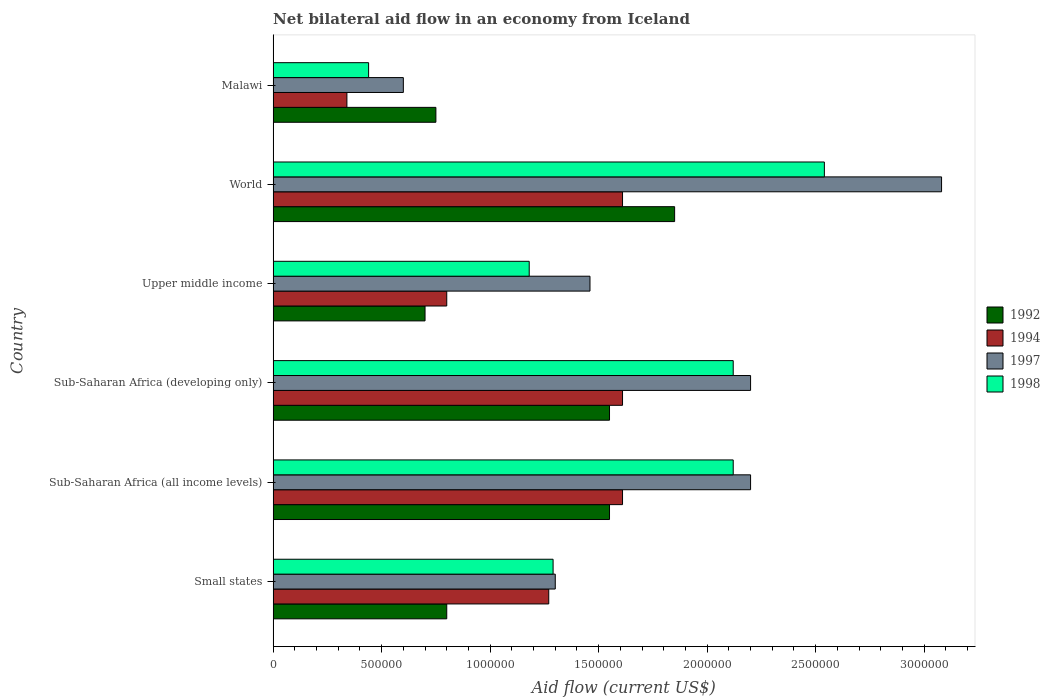How many groups of bars are there?
Provide a succinct answer. 6. Are the number of bars per tick equal to the number of legend labels?
Keep it short and to the point. Yes. Are the number of bars on each tick of the Y-axis equal?
Your answer should be compact. Yes. What is the label of the 4th group of bars from the top?
Your answer should be very brief. Sub-Saharan Africa (developing only). What is the net bilateral aid flow in 1997 in Upper middle income?
Your response must be concise. 1.46e+06. Across all countries, what is the maximum net bilateral aid flow in 1994?
Your response must be concise. 1.61e+06. Across all countries, what is the minimum net bilateral aid flow in 1994?
Provide a succinct answer. 3.40e+05. In which country was the net bilateral aid flow in 1992 minimum?
Give a very brief answer. Upper middle income. What is the total net bilateral aid flow in 1992 in the graph?
Offer a very short reply. 7.20e+06. What is the difference between the net bilateral aid flow in 1998 in Malawi and that in World?
Your answer should be compact. -2.10e+06. What is the difference between the net bilateral aid flow in 1994 in Sub-Saharan Africa (all income levels) and the net bilateral aid flow in 1992 in World?
Offer a very short reply. -2.40e+05. What is the average net bilateral aid flow in 1998 per country?
Make the answer very short. 1.62e+06. What is the difference between the net bilateral aid flow in 1998 and net bilateral aid flow in 1997 in Malawi?
Make the answer very short. -1.60e+05. What is the ratio of the net bilateral aid flow in 1998 in Malawi to that in World?
Keep it short and to the point. 0.17. What is the difference between the highest and the second highest net bilateral aid flow in 1997?
Make the answer very short. 8.80e+05. What is the difference between the highest and the lowest net bilateral aid flow in 1997?
Ensure brevity in your answer.  2.48e+06. What does the 3rd bar from the bottom in Upper middle income represents?
Your answer should be compact. 1997. Is it the case that in every country, the sum of the net bilateral aid flow in 1997 and net bilateral aid flow in 1992 is greater than the net bilateral aid flow in 1994?
Your answer should be very brief. Yes. Are all the bars in the graph horizontal?
Provide a short and direct response. Yes. Does the graph contain grids?
Make the answer very short. No. Where does the legend appear in the graph?
Your answer should be very brief. Center right. How are the legend labels stacked?
Keep it short and to the point. Vertical. What is the title of the graph?
Your answer should be compact. Net bilateral aid flow in an economy from Iceland. What is the Aid flow (current US$) of 1994 in Small states?
Your answer should be compact. 1.27e+06. What is the Aid flow (current US$) in 1997 in Small states?
Your response must be concise. 1.30e+06. What is the Aid flow (current US$) in 1998 in Small states?
Your answer should be compact. 1.29e+06. What is the Aid flow (current US$) of 1992 in Sub-Saharan Africa (all income levels)?
Keep it short and to the point. 1.55e+06. What is the Aid flow (current US$) of 1994 in Sub-Saharan Africa (all income levels)?
Your response must be concise. 1.61e+06. What is the Aid flow (current US$) of 1997 in Sub-Saharan Africa (all income levels)?
Provide a succinct answer. 2.20e+06. What is the Aid flow (current US$) of 1998 in Sub-Saharan Africa (all income levels)?
Keep it short and to the point. 2.12e+06. What is the Aid flow (current US$) in 1992 in Sub-Saharan Africa (developing only)?
Your response must be concise. 1.55e+06. What is the Aid flow (current US$) in 1994 in Sub-Saharan Africa (developing only)?
Provide a short and direct response. 1.61e+06. What is the Aid flow (current US$) in 1997 in Sub-Saharan Africa (developing only)?
Ensure brevity in your answer.  2.20e+06. What is the Aid flow (current US$) in 1998 in Sub-Saharan Africa (developing only)?
Ensure brevity in your answer.  2.12e+06. What is the Aid flow (current US$) of 1992 in Upper middle income?
Give a very brief answer. 7.00e+05. What is the Aid flow (current US$) of 1994 in Upper middle income?
Provide a short and direct response. 8.00e+05. What is the Aid flow (current US$) in 1997 in Upper middle income?
Keep it short and to the point. 1.46e+06. What is the Aid flow (current US$) in 1998 in Upper middle income?
Offer a terse response. 1.18e+06. What is the Aid flow (current US$) of 1992 in World?
Make the answer very short. 1.85e+06. What is the Aid flow (current US$) of 1994 in World?
Your response must be concise. 1.61e+06. What is the Aid flow (current US$) in 1997 in World?
Provide a succinct answer. 3.08e+06. What is the Aid flow (current US$) of 1998 in World?
Provide a succinct answer. 2.54e+06. What is the Aid flow (current US$) of 1992 in Malawi?
Your answer should be very brief. 7.50e+05. Across all countries, what is the maximum Aid flow (current US$) in 1992?
Ensure brevity in your answer.  1.85e+06. Across all countries, what is the maximum Aid flow (current US$) of 1994?
Provide a succinct answer. 1.61e+06. Across all countries, what is the maximum Aid flow (current US$) of 1997?
Ensure brevity in your answer.  3.08e+06. Across all countries, what is the maximum Aid flow (current US$) of 1998?
Your answer should be very brief. 2.54e+06. Across all countries, what is the minimum Aid flow (current US$) of 1992?
Offer a very short reply. 7.00e+05. Across all countries, what is the minimum Aid flow (current US$) in 1997?
Offer a very short reply. 6.00e+05. What is the total Aid flow (current US$) in 1992 in the graph?
Keep it short and to the point. 7.20e+06. What is the total Aid flow (current US$) in 1994 in the graph?
Offer a very short reply. 7.24e+06. What is the total Aid flow (current US$) of 1997 in the graph?
Offer a terse response. 1.08e+07. What is the total Aid flow (current US$) in 1998 in the graph?
Your response must be concise. 9.69e+06. What is the difference between the Aid flow (current US$) in 1992 in Small states and that in Sub-Saharan Africa (all income levels)?
Your answer should be compact. -7.50e+05. What is the difference between the Aid flow (current US$) in 1997 in Small states and that in Sub-Saharan Africa (all income levels)?
Provide a succinct answer. -9.00e+05. What is the difference between the Aid flow (current US$) of 1998 in Small states and that in Sub-Saharan Africa (all income levels)?
Provide a short and direct response. -8.30e+05. What is the difference between the Aid flow (current US$) of 1992 in Small states and that in Sub-Saharan Africa (developing only)?
Make the answer very short. -7.50e+05. What is the difference between the Aid flow (current US$) in 1997 in Small states and that in Sub-Saharan Africa (developing only)?
Offer a terse response. -9.00e+05. What is the difference between the Aid flow (current US$) of 1998 in Small states and that in Sub-Saharan Africa (developing only)?
Ensure brevity in your answer.  -8.30e+05. What is the difference between the Aid flow (current US$) in 1992 in Small states and that in Upper middle income?
Offer a very short reply. 1.00e+05. What is the difference between the Aid flow (current US$) of 1994 in Small states and that in Upper middle income?
Provide a short and direct response. 4.70e+05. What is the difference between the Aid flow (current US$) in 1992 in Small states and that in World?
Offer a terse response. -1.05e+06. What is the difference between the Aid flow (current US$) in 1994 in Small states and that in World?
Offer a terse response. -3.40e+05. What is the difference between the Aid flow (current US$) of 1997 in Small states and that in World?
Offer a very short reply. -1.78e+06. What is the difference between the Aid flow (current US$) in 1998 in Small states and that in World?
Provide a succinct answer. -1.25e+06. What is the difference between the Aid flow (current US$) in 1994 in Small states and that in Malawi?
Offer a very short reply. 9.30e+05. What is the difference between the Aid flow (current US$) in 1997 in Small states and that in Malawi?
Ensure brevity in your answer.  7.00e+05. What is the difference between the Aid flow (current US$) in 1998 in Small states and that in Malawi?
Keep it short and to the point. 8.50e+05. What is the difference between the Aid flow (current US$) in 1997 in Sub-Saharan Africa (all income levels) and that in Sub-Saharan Africa (developing only)?
Ensure brevity in your answer.  0. What is the difference between the Aid flow (current US$) of 1992 in Sub-Saharan Africa (all income levels) and that in Upper middle income?
Make the answer very short. 8.50e+05. What is the difference between the Aid flow (current US$) in 1994 in Sub-Saharan Africa (all income levels) and that in Upper middle income?
Offer a terse response. 8.10e+05. What is the difference between the Aid flow (current US$) of 1997 in Sub-Saharan Africa (all income levels) and that in Upper middle income?
Offer a very short reply. 7.40e+05. What is the difference between the Aid flow (current US$) in 1998 in Sub-Saharan Africa (all income levels) and that in Upper middle income?
Offer a very short reply. 9.40e+05. What is the difference between the Aid flow (current US$) in 1992 in Sub-Saharan Africa (all income levels) and that in World?
Ensure brevity in your answer.  -3.00e+05. What is the difference between the Aid flow (current US$) of 1994 in Sub-Saharan Africa (all income levels) and that in World?
Offer a terse response. 0. What is the difference between the Aid flow (current US$) of 1997 in Sub-Saharan Africa (all income levels) and that in World?
Give a very brief answer. -8.80e+05. What is the difference between the Aid flow (current US$) in 1998 in Sub-Saharan Africa (all income levels) and that in World?
Give a very brief answer. -4.20e+05. What is the difference between the Aid flow (current US$) in 1992 in Sub-Saharan Africa (all income levels) and that in Malawi?
Offer a terse response. 8.00e+05. What is the difference between the Aid flow (current US$) of 1994 in Sub-Saharan Africa (all income levels) and that in Malawi?
Keep it short and to the point. 1.27e+06. What is the difference between the Aid flow (current US$) of 1997 in Sub-Saharan Africa (all income levels) and that in Malawi?
Offer a terse response. 1.60e+06. What is the difference between the Aid flow (current US$) in 1998 in Sub-Saharan Africa (all income levels) and that in Malawi?
Keep it short and to the point. 1.68e+06. What is the difference between the Aid flow (current US$) of 1992 in Sub-Saharan Africa (developing only) and that in Upper middle income?
Give a very brief answer. 8.50e+05. What is the difference between the Aid flow (current US$) in 1994 in Sub-Saharan Africa (developing only) and that in Upper middle income?
Your answer should be very brief. 8.10e+05. What is the difference between the Aid flow (current US$) in 1997 in Sub-Saharan Africa (developing only) and that in Upper middle income?
Ensure brevity in your answer.  7.40e+05. What is the difference between the Aid flow (current US$) in 1998 in Sub-Saharan Africa (developing only) and that in Upper middle income?
Offer a very short reply. 9.40e+05. What is the difference between the Aid flow (current US$) in 1992 in Sub-Saharan Africa (developing only) and that in World?
Give a very brief answer. -3.00e+05. What is the difference between the Aid flow (current US$) in 1994 in Sub-Saharan Africa (developing only) and that in World?
Offer a terse response. 0. What is the difference between the Aid flow (current US$) in 1997 in Sub-Saharan Africa (developing only) and that in World?
Your answer should be very brief. -8.80e+05. What is the difference between the Aid flow (current US$) in 1998 in Sub-Saharan Africa (developing only) and that in World?
Your answer should be compact. -4.20e+05. What is the difference between the Aid flow (current US$) in 1992 in Sub-Saharan Africa (developing only) and that in Malawi?
Keep it short and to the point. 8.00e+05. What is the difference between the Aid flow (current US$) in 1994 in Sub-Saharan Africa (developing only) and that in Malawi?
Give a very brief answer. 1.27e+06. What is the difference between the Aid flow (current US$) in 1997 in Sub-Saharan Africa (developing only) and that in Malawi?
Your answer should be very brief. 1.60e+06. What is the difference between the Aid flow (current US$) of 1998 in Sub-Saharan Africa (developing only) and that in Malawi?
Your response must be concise. 1.68e+06. What is the difference between the Aid flow (current US$) in 1992 in Upper middle income and that in World?
Your answer should be very brief. -1.15e+06. What is the difference between the Aid flow (current US$) of 1994 in Upper middle income and that in World?
Provide a short and direct response. -8.10e+05. What is the difference between the Aid flow (current US$) of 1997 in Upper middle income and that in World?
Make the answer very short. -1.62e+06. What is the difference between the Aid flow (current US$) of 1998 in Upper middle income and that in World?
Your response must be concise. -1.36e+06. What is the difference between the Aid flow (current US$) of 1992 in Upper middle income and that in Malawi?
Give a very brief answer. -5.00e+04. What is the difference between the Aid flow (current US$) in 1997 in Upper middle income and that in Malawi?
Provide a short and direct response. 8.60e+05. What is the difference between the Aid flow (current US$) of 1998 in Upper middle income and that in Malawi?
Ensure brevity in your answer.  7.40e+05. What is the difference between the Aid flow (current US$) of 1992 in World and that in Malawi?
Provide a succinct answer. 1.10e+06. What is the difference between the Aid flow (current US$) of 1994 in World and that in Malawi?
Your response must be concise. 1.27e+06. What is the difference between the Aid flow (current US$) in 1997 in World and that in Malawi?
Provide a short and direct response. 2.48e+06. What is the difference between the Aid flow (current US$) of 1998 in World and that in Malawi?
Your answer should be very brief. 2.10e+06. What is the difference between the Aid flow (current US$) of 1992 in Small states and the Aid flow (current US$) of 1994 in Sub-Saharan Africa (all income levels)?
Keep it short and to the point. -8.10e+05. What is the difference between the Aid flow (current US$) of 1992 in Small states and the Aid flow (current US$) of 1997 in Sub-Saharan Africa (all income levels)?
Provide a succinct answer. -1.40e+06. What is the difference between the Aid flow (current US$) in 1992 in Small states and the Aid flow (current US$) in 1998 in Sub-Saharan Africa (all income levels)?
Provide a short and direct response. -1.32e+06. What is the difference between the Aid flow (current US$) of 1994 in Small states and the Aid flow (current US$) of 1997 in Sub-Saharan Africa (all income levels)?
Ensure brevity in your answer.  -9.30e+05. What is the difference between the Aid flow (current US$) in 1994 in Small states and the Aid flow (current US$) in 1998 in Sub-Saharan Africa (all income levels)?
Your answer should be very brief. -8.50e+05. What is the difference between the Aid flow (current US$) of 1997 in Small states and the Aid flow (current US$) of 1998 in Sub-Saharan Africa (all income levels)?
Provide a succinct answer. -8.20e+05. What is the difference between the Aid flow (current US$) of 1992 in Small states and the Aid flow (current US$) of 1994 in Sub-Saharan Africa (developing only)?
Your answer should be compact. -8.10e+05. What is the difference between the Aid flow (current US$) of 1992 in Small states and the Aid flow (current US$) of 1997 in Sub-Saharan Africa (developing only)?
Provide a short and direct response. -1.40e+06. What is the difference between the Aid flow (current US$) of 1992 in Small states and the Aid flow (current US$) of 1998 in Sub-Saharan Africa (developing only)?
Offer a very short reply. -1.32e+06. What is the difference between the Aid flow (current US$) of 1994 in Small states and the Aid flow (current US$) of 1997 in Sub-Saharan Africa (developing only)?
Offer a terse response. -9.30e+05. What is the difference between the Aid flow (current US$) in 1994 in Small states and the Aid flow (current US$) in 1998 in Sub-Saharan Africa (developing only)?
Provide a succinct answer. -8.50e+05. What is the difference between the Aid flow (current US$) of 1997 in Small states and the Aid flow (current US$) of 1998 in Sub-Saharan Africa (developing only)?
Ensure brevity in your answer.  -8.20e+05. What is the difference between the Aid flow (current US$) of 1992 in Small states and the Aid flow (current US$) of 1997 in Upper middle income?
Your answer should be compact. -6.60e+05. What is the difference between the Aid flow (current US$) of 1992 in Small states and the Aid flow (current US$) of 1998 in Upper middle income?
Provide a succinct answer. -3.80e+05. What is the difference between the Aid flow (current US$) in 1994 in Small states and the Aid flow (current US$) in 1997 in Upper middle income?
Your answer should be compact. -1.90e+05. What is the difference between the Aid flow (current US$) in 1992 in Small states and the Aid flow (current US$) in 1994 in World?
Offer a terse response. -8.10e+05. What is the difference between the Aid flow (current US$) of 1992 in Small states and the Aid flow (current US$) of 1997 in World?
Your answer should be compact. -2.28e+06. What is the difference between the Aid flow (current US$) of 1992 in Small states and the Aid flow (current US$) of 1998 in World?
Your answer should be compact. -1.74e+06. What is the difference between the Aid flow (current US$) of 1994 in Small states and the Aid flow (current US$) of 1997 in World?
Your response must be concise. -1.81e+06. What is the difference between the Aid flow (current US$) of 1994 in Small states and the Aid flow (current US$) of 1998 in World?
Keep it short and to the point. -1.27e+06. What is the difference between the Aid flow (current US$) in 1997 in Small states and the Aid flow (current US$) in 1998 in World?
Your response must be concise. -1.24e+06. What is the difference between the Aid flow (current US$) in 1992 in Small states and the Aid flow (current US$) in 1997 in Malawi?
Provide a succinct answer. 2.00e+05. What is the difference between the Aid flow (current US$) of 1994 in Small states and the Aid flow (current US$) of 1997 in Malawi?
Offer a terse response. 6.70e+05. What is the difference between the Aid flow (current US$) in 1994 in Small states and the Aid flow (current US$) in 1998 in Malawi?
Make the answer very short. 8.30e+05. What is the difference between the Aid flow (current US$) of 1997 in Small states and the Aid flow (current US$) of 1998 in Malawi?
Your response must be concise. 8.60e+05. What is the difference between the Aid flow (current US$) of 1992 in Sub-Saharan Africa (all income levels) and the Aid flow (current US$) of 1997 in Sub-Saharan Africa (developing only)?
Provide a short and direct response. -6.50e+05. What is the difference between the Aid flow (current US$) in 1992 in Sub-Saharan Africa (all income levels) and the Aid flow (current US$) in 1998 in Sub-Saharan Africa (developing only)?
Ensure brevity in your answer.  -5.70e+05. What is the difference between the Aid flow (current US$) of 1994 in Sub-Saharan Africa (all income levels) and the Aid flow (current US$) of 1997 in Sub-Saharan Africa (developing only)?
Provide a succinct answer. -5.90e+05. What is the difference between the Aid flow (current US$) in 1994 in Sub-Saharan Africa (all income levels) and the Aid flow (current US$) in 1998 in Sub-Saharan Africa (developing only)?
Your answer should be compact. -5.10e+05. What is the difference between the Aid flow (current US$) of 1992 in Sub-Saharan Africa (all income levels) and the Aid flow (current US$) of 1994 in Upper middle income?
Provide a short and direct response. 7.50e+05. What is the difference between the Aid flow (current US$) of 1992 in Sub-Saharan Africa (all income levels) and the Aid flow (current US$) of 1997 in Upper middle income?
Provide a short and direct response. 9.00e+04. What is the difference between the Aid flow (current US$) in 1997 in Sub-Saharan Africa (all income levels) and the Aid flow (current US$) in 1998 in Upper middle income?
Ensure brevity in your answer.  1.02e+06. What is the difference between the Aid flow (current US$) in 1992 in Sub-Saharan Africa (all income levels) and the Aid flow (current US$) in 1997 in World?
Your answer should be very brief. -1.53e+06. What is the difference between the Aid flow (current US$) of 1992 in Sub-Saharan Africa (all income levels) and the Aid flow (current US$) of 1998 in World?
Your answer should be very brief. -9.90e+05. What is the difference between the Aid flow (current US$) in 1994 in Sub-Saharan Africa (all income levels) and the Aid flow (current US$) in 1997 in World?
Your response must be concise. -1.47e+06. What is the difference between the Aid flow (current US$) of 1994 in Sub-Saharan Africa (all income levels) and the Aid flow (current US$) of 1998 in World?
Provide a succinct answer. -9.30e+05. What is the difference between the Aid flow (current US$) in 1992 in Sub-Saharan Africa (all income levels) and the Aid flow (current US$) in 1994 in Malawi?
Make the answer very short. 1.21e+06. What is the difference between the Aid flow (current US$) of 1992 in Sub-Saharan Africa (all income levels) and the Aid flow (current US$) of 1997 in Malawi?
Provide a short and direct response. 9.50e+05. What is the difference between the Aid flow (current US$) in 1992 in Sub-Saharan Africa (all income levels) and the Aid flow (current US$) in 1998 in Malawi?
Provide a short and direct response. 1.11e+06. What is the difference between the Aid flow (current US$) of 1994 in Sub-Saharan Africa (all income levels) and the Aid flow (current US$) of 1997 in Malawi?
Make the answer very short. 1.01e+06. What is the difference between the Aid flow (current US$) of 1994 in Sub-Saharan Africa (all income levels) and the Aid flow (current US$) of 1998 in Malawi?
Your answer should be compact. 1.17e+06. What is the difference between the Aid flow (current US$) of 1997 in Sub-Saharan Africa (all income levels) and the Aid flow (current US$) of 1998 in Malawi?
Provide a short and direct response. 1.76e+06. What is the difference between the Aid flow (current US$) of 1992 in Sub-Saharan Africa (developing only) and the Aid flow (current US$) of 1994 in Upper middle income?
Offer a very short reply. 7.50e+05. What is the difference between the Aid flow (current US$) in 1992 in Sub-Saharan Africa (developing only) and the Aid flow (current US$) in 1998 in Upper middle income?
Keep it short and to the point. 3.70e+05. What is the difference between the Aid flow (current US$) in 1997 in Sub-Saharan Africa (developing only) and the Aid flow (current US$) in 1998 in Upper middle income?
Offer a very short reply. 1.02e+06. What is the difference between the Aid flow (current US$) in 1992 in Sub-Saharan Africa (developing only) and the Aid flow (current US$) in 1994 in World?
Ensure brevity in your answer.  -6.00e+04. What is the difference between the Aid flow (current US$) in 1992 in Sub-Saharan Africa (developing only) and the Aid flow (current US$) in 1997 in World?
Keep it short and to the point. -1.53e+06. What is the difference between the Aid flow (current US$) of 1992 in Sub-Saharan Africa (developing only) and the Aid flow (current US$) of 1998 in World?
Provide a short and direct response. -9.90e+05. What is the difference between the Aid flow (current US$) of 1994 in Sub-Saharan Africa (developing only) and the Aid flow (current US$) of 1997 in World?
Keep it short and to the point. -1.47e+06. What is the difference between the Aid flow (current US$) in 1994 in Sub-Saharan Africa (developing only) and the Aid flow (current US$) in 1998 in World?
Provide a short and direct response. -9.30e+05. What is the difference between the Aid flow (current US$) of 1992 in Sub-Saharan Africa (developing only) and the Aid flow (current US$) of 1994 in Malawi?
Provide a succinct answer. 1.21e+06. What is the difference between the Aid flow (current US$) of 1992 in Sub-Saharan Africa (developing only) and the Aid flow (current US$) of 1997 in Malawi?
Make the answer very short. 9.50e+05. What is the difference between the Aid flow (current US$) in 1992 in Sub-Saharan Africa (developing only) and the Aid flow (current US$) in 1998 in Malawi?
Ensure brevity in your answer.  1.11e+06. What is the difference between the Aid flow (current US$) in 1994 in Sub-Saharan Africa (developing only) and the Aid flow (current US$) in 1997 in Malawi?
Your answer should be very brief. 1.01e+06. What is the difference between the Aid flow (current US$) in 1994 in Sub-Saharan Africa (developing only) and the Aid flow (current US$) in 1998 in Malawi?
Provide a succinct answer. 1.17e+06. What is the difference between the Aid flow (current US$) of 1997 in Sub-Saharan Africa (developing only) and the Aid flow (current US$) of 1998 in Malawi?
Provide a succinct answer. 1.76e+06. What is the difference between the Aid flow (current US$) in 1992 in Upper middle income and the Aid flow (current US$) in 1994 in World?
Your answer should be very brief. -9.10e+05. What is the difference between the Aid flow (current US$) of 1992 in Upper middle income and the Aid flow (current US$) of 1997 in World?
Give a very brief answer. -2.38e+06. What is the difference between the Aid flow (current US$) in 1992 in Upper middle income and the Aid flow (current US$) in 1998 in World?
Provide a succinct answer. -1.84e+06. What is the difference between the Aid flow (current US$) in 1994 in Upper middle income and the Aid flow (current US$) in 1997 in World?
Provide a succinct answer. -2.28e+06. What is the difference between the Aid flow (current US$) in 1994 in Upper middle income and the Aid flow (current US$) in 1998 in World?
Provide a short and direct response. -1.74e+06. What is the difference between the Aid flow (current US$) in 1997 in Upper middle income and the Aid flow (current US$) in 1998 in World?
Your answer should be compact. -1.08e+06. What is the difference between the Aid flow (current US$) of 1992 in Upper middle income and the Aid flow (current US$) of 1997 in Malawi?
Your answer should be compact. 1.00e+05. What is the difference between the Aid flow (current US$) in 1992 in Upper middle income and the Aid flow (current US$) in 1998 in Malawi?
Make the answer very short. 2.60e+05. What is the difference between the Aid flow (current US$) of 1994 in Upper middle income and the Aid flow (current US$) of 1997 in Malawi?
Make the answer very short. 2.00e+05. What is the difference between the Aid flow (current US$) in 1997 in Upper middle income and the Aid flow (current US$) in 1998 in Malawi?
Keep it short and to the point. 1.02e+06. What is the difference between the Aid flow (current US$) in 1992 in World and the Aid flow (current US$) in 1994 in Malawi?
Ensure brevity in your answer.  1.51e+06. What is the difference between the Aid flow (current US$) in 1992 in World and the Aid flow (current US$) in 1997 in Malawi?
Provide a short and direct response. 1.25e+06. What is the difference between the Aid flow (current US$) of 1992 in World and the Aid flow (current US$) of 1998 in Malawi?
Keep it short and to the point. 1.41e+06. What is the difference between the Aid flow (current US$) in 1994 in World and the Aid flow (current US$) in 1997 in Malawi?
Make the answer very short. 1.01e+06. What is the difference between the Aid flow (current US$) of 1994 in World and the Aid flow (current US$) of 1998 in Malawi?
Your answer should be very brief. 1.17e+06. What is the difference between the Aid flow (current US$) of 1997 in World and the Aid flow (current US$) of 1998 in Malawi?
Give a very brief answer. 2.64e+06. What is the average Aid flow (current US$) of 1992 per country?
Provide a succinct answer. 1.20e+06. What is the average Aid flow (current US$) in 1994 per country?
Keep it short and to the point. 1.21e+06. What is the average Aid flow (current US$) of 1997 per country?
Provide a succinct answer. 1.81e+06. What is the average Aid flow (current US$) of 1998 per country?
Ensure brevity in your answer.  1.62e+06. What is the difference between the Aid flow (current US$) in 1992 and Aid flow (current US$) in 1994 in Small states?
Give a very brief answer. -4.70e+05. What is the difference between the Aid flow (current US$) of 1992 and Aid flow (current US$) of 1997 in Small states?
Provide a succinct answer. -5.00e+05. What is the difference between the Aid flow (current US$) in 1992 and Aid flow (current US$) in 1998 in Small states?
Your response must be concise. -4.90e+05. What is the difference between the Aid flow (current US$) of 1992 and Aid flow (current US$) of 1997 in Sub-Saharan Africa (all income levels)?
Provide a succinct answer. -6.50e+05. What is the difference between the Aid flow (current US$) of 1992 and Aid flow (current US$) of 1998 in Sub-Saharan Africa (all income levels)?
Your answer should be very brief. -5.70e+05. What is the difference between the Aid flow (current US$) in 1994 and Aid flow (current US$) in 1997 in Sub-Saharan Africa (all income levels)?
Provide a short and direct response. -5.90e+05. What is the difference between the Aid flow (current US$) in 1994 and Aid flow (current US$) in 1998 in Sub-Saharan Africa (all income levels)?
Your answer should be compact. -5.10e+05. What is the difference between the Aid flow (current US$) of 1992 and Aid flow (current US$) of 1994 in Sub-Saharan Africa (developing only)?
Your answer should be compact. -6.00e+04. What is the difference between the Aid flow (current US$) in 1992 and Aid flow (current US$) in 1997 in Sub-Saharan Africa (developing only)?
Offer a terse response. -6.50e+05. What is the difference between the Aid flow (current US$) of 1992 and Aid flow (current US$) of 1998 in Sub-Saharan Africa (developing only)?
Provide a succinct answer. -5.70e+05. What is the difference between the Aid flow (current US$) in 1994 and Aid flow (current US$) in 1997 in Sub-Saharan Africa (developing only)?
Give a very brief answer. -5.90e+05. What is the difference between the Aid flow (current US$) in 1994 and Aid flow (current US$) in 1998 in Sub-Saharan Africa (developing only)?
Ensure brevity in your answer.  -5.10e+05. What is the difference between the Aid flow (current US$) of 1997 and Aid flow (current US$) of 1998 in Sub-Saharan Africa (developing only)?
Offer a terse response. 8.00e+04. What is the difference between the Aid flow (current US$) in 1992 and Aid flow (current US$) in 1997 in Upper middle income?
Provide a short and direct response. -7.60e+05. What is the difference between the Aid flow (current US$) of 1992 and Aid flow (current US$) of 1998 in Upper middle income?
Make the answer very short. -4.80e+05. What is the difference between the Aid flow (current US$) of 1994 and Aid flow (current US$) of 1997 in Upper middle income?
Provide a short and direct response. -6.60e+05. What is the difference between the Aid flow (current US$) in 1994 and Aid flow (current US$) in 1998 in Upper middle income?
Make the answer very short. -3.80e+05. What is the difference between the Aid flow (current US$) of 1997 and Aid flow (current US$) of 1998 in Upper middle income?
Ensure brevity in your answer.  2.80e+05. What is the difference between the Aid flow (current US$) in 1992 and Aid flow (current US$) in 1997 in World?
Make the answer very short. -1.23e+06. What is the difference between the Aid flow (current US$) of 1992 and Aid flow (current US$) of 1998 in World?
Your answer should be compact. -6.90e+05. What is the difference between the Aid flow (current US$) of 1994 and Aid flow (current US$) of 1997 in World?
Ensure brevity in your answer.  -1.47e+06. What is the difference between the Aid flow (current US$) in 1994 and Aid flow (current US$) in 1998 in World?
Make the answer very short. -9.30e+05. What is the difference between the Aid flow (current US$) in 1997 and Aid flow (current US$) in 1998 in World?
Provide a short and direct response. 5.40e+05. What is the difference between the Aid flow (current US$) in 1992 and Aid flow (current US$) in 1997 in Malawi?
Offer a very short reply. 1.50e+05. What is the difference between the Aid flow (current US$) of 1992 and Aid flow (current US$) of 1998 in Malawi?
Offer a very short reply. 3.10e+05. What is the difference between the Aid flow (current US$) in 1994 and Aid flow (current US$) in 1997 in Malawi?
Provide a succinct answer. -2.60e+05. What is the difference between the Aid flow (current US$) in 1994 and Aid flow (current US$) in 1998 in Malawi?
Your response must be concise. -1.00e+05. What is the difference between the Aid flow (current US$) in 1997 and Aid flow (current US$) in 1998 in Malawi?
Your answer should be compact. 1.60e+05. What is the ratio of the Aid flow (current US$) in 1992 in Small states to that in Sub-Saharan Africa (all income levels)?
Your response must be concise. 0.52. What is the ratio of the Aid flow (current US$) of 1994 in Small states to that in Sub-Saharan Africa (all income levels)?
Provide a short and direct response. 0.79. What is the ratio of the Aid flow (current US$) in 1997 in Small states to that in Sub-Saharan Africa (all income levels)?
Your answer should be very brief. 0.59. What is the ratio of the Aid flow (current US$) of 1998 in Small states to that in Sub-Saharan Africa (all income levels)?
Offer a terse response. 0.61. What is the ratio of the Aid flow (current US$) in 1992 in Small states to that in Sub-Saharan Africa (developing only)?
Offer a very short reply. 0.52. What is the ratio of the Aid flow (current US$) in 1994 in Small states to that in Sub-Saharan Africa (developing only)?
Ensure brevity in your answer.  0.79. What is the ratio of the Aid flow (current US$) in 1997 in Small states to that in Sub-Saharan Africa (developing only)?
Provide a succinct answer. 0.59. What is the ratio of the Aid flow (current US$) of 1998 in Small states to that in Sub-Saharan Africa (developing only)?
Your answer should be compact. 0.61. What is the ratio of the Aid flow (current US$) in 1992 in Small states to that in Upper middle income?
Your answer should be very brief. 1.14. What is the ratio of the Aid flow (current US$) in 1994 in Small states to that in Upper middle income?
Offer a very short reply. 1.59. What is the ratio of the Aid flow (current US$) in 1997 in Small states to that in Upper middle income?
Ensure brevity in your answer.  0.89. What is the ratio of the Aid flow (current US$) of 1998 in Small states to that in Upper middle income?
Offer a terse response. 1.09. What is the ratio of the Aid flow (current US$) in 1992 in Small states to that in World?
Your response must be concise. 0.43. What is the ratio of the Aid flow (current US$) in 1994 in Small states to that in World?
Make the answer very short. 0.79. What is the ratio of the Aid flow (current US$) in 1997 in Small states to that in World?
Give a very brief answer. 0.42. What is the ratio of the Aid flow (current US$) in 1998 in Small states to that in World?
Offer a very short reply. 0.51. What is the ratio of the Aid flow (current US$) of 1992 in Small states to that in Malawi?
Ensure brevity in your answer.  1.07. What is the ratio of the Aid flow (current US$) of 1994 in Small states to that in Malawi?
Offer a terse response. 3.74. What is the ratio of the Aid flow (current US$) in 1997 in Small states to that in Malawi?
Offer a very short reply. 2.17. What is the ratio of the Aid flow (current US$) in 1998 in Small states to that in Malawi?
Keep it short and to the point. 2.93. What is the ratio of the Aid flow (current US$) in 1992 in Sub-Saharan Africa (all income levels) to that in Sub-Saharan Africa (developing only)?
Ensure brevity in your answer.  1. What is the ratio of the Aid flow (current US$) of 1994 in Sub-Saharan Africa (all income levels) to that in Sub-Saharan Africa (developing only)?
Make the answer very short. 1. What is the ratio of the Aid flow (current US$) of 1992 in Sub-Saharan Africa (all income levels) to that in Upper middle income?
Make the answer very short. 2.21. What is the ratio of the Aid flow (current US$) of 1994 in Sub-Saharan Africa (all income levels) to that in Upper middle income?
Ensure brevity in your answer.  2.01. What is the ratio of the Aid flow (current US$) in 1997 in Sub-Saharan Africa (all income levels) to that in Upper middle income?
Ensure brevity in your answer.  1.51. What is the ratio of the Aid flow (current US$) of 1998 in Sub-Saharan Africa (all income levels) to that in Upper middle income?
Keep it short and to the point. 1.8. What is the ratio of the Aid flow (current US$) of 1992 in Sub-Saharan Africa (all income levels) to that in World?
Offer a terse response. 0.84. What is the ratio of the Aid flow (current US$) of 1998 in Sub-Saharan Africa (all income levels) to that in World?
Give a very brief answer. 0.83. What is the ratio of the Aid flow (current US$) of 1992 in Sub-Saharan Africa (all income levels) to that in Malawi?
Give a very brief answer. 2.07. What is the ratio of the Aid flow (current US$) in 1994 in Sub-Saharan Africa (all income levels) to that in Malawi?
Ensure brevity in your answer.  4.74. What is the ratio of the Aid flow (current US$) in 1997 in Sub-Saharan Africa (all income levels) to that in Malawi?
Provide a short and direct response. 3.67. What is the ratio of the Aid flow (current US$) of 1998 in Sub-Saharan Africa (all income levels) to that in Malawi?
Keep it short and to the point. 4.82. What is the ratio of the Aid flow (current US$) of 1992 in Sub-Saharan Africa (developing only) to that in Upper middle income?
Keep it short and to the point. 2.21. What is the ratio of the Aid flow (current US$) in 1994 in Sub-Saharan Africa (developing only) to that in Upper middle income?
Ensure brevity in your answer.  2.01. What is the ratio of the Aid flow (current US$) in 1997 in Sub-Saharan Africa (developing only) to that in Upper middle income?
Provide a succinct answer. 1.51. What is the ratio of the Aid flow (current US$) in 1998 in Sub-Saharan Africa (developing only) to that in Upper middle income?
Offer a very short reply. 1.8. What is the ratio of the Aid flow (current US$) in 1992 in Sub-Saharan Africa (developing only) to that in World?
Ensure brevity in your answer.  0.84. What is the ratio of the Aid flow (current US$) of 1997 in Sub-Saharan Africa (developing only) to that in World?
Your response must be concise. 0.71. What is the ratio of the Aid flow (current US$) of 1998 in Sub-Saharan Africa (developing only) to that in World?
Offer a very short reply. 0.83. What is the ratio of the Aid flow (current US$) of 1992 in Sub-Saharan Africa (developing only) to that in Malawi?
Ensure brevity in your answer.  2.07. What is the ratio of the Aid flow (current US$) of 1994 in Sub-Saharan Africa (developing only) to that in Malawi?
Your answer should be very brief. 4.74. What is the ratio of the Aid flow (current US$) in 1997 in Sub-Saharan Africa (developing only) to that in Malawi?
Your response must be concise. 3.67. What is the ratio of the Aid flow (current US$) of 1998 in Sub-Saharan Africa (developing only) to that in Malawi?
Make the answer very short. 4.82. What is the ratio of the Aid flow (current US$) of 1992 in Upper middle income to that in World?
Provide a succinct answer. 0.38. What is the ratio of the Aid flow (current US$) in 1994 in Upper middle income to that in World?
Keep it short and to the point. 0.5. What is the ratio of the Aid flow (current US$) in 1997 in Upper middle income to that in World?
Ensure brevity in your answer.  0.47. What is the ratio of the Aid flow (current US$) of 1998 in Upper middle income to that in World?
Ensure brevity in your answer.  0.46. What is the ratio of the Aid flow (current US$) in 1994 in Upper middle income to that in Malawi?
Offer a terse response. 2.35. What is the ratio of the Aid flow (current US$) in 1997 in Upper middle income to that in Malawi?
Ensure brevity in your answer.  2.43. What is the ratio of the Aid flow (current US$) in 1998 in Upper middle income to that in Malawi?
Your response must be concise. 2.68. What is the ratio of the Aid flow (current US$) in 1992 in World to that in Malawi?
Your response must be concise. 2.47. What is the ratio of the Aid flow (current US$) of 1994 in World to that in Malawi?
Offer a terse response. 4.74. What is the ratio of the Aid flow (current US$) of 1997 in World to that in Malawi?
Offer a terse response. 5.13. What is the ratio of the Aid flow (current US$) in 1998 in World to that in Malawi?
Your response must be concise. 5.77. What is the difference between the highest and the second highest Aid flow (current US$) in 1992?
Your answer should be very brief. 3.00e+05. What is the difference between the highest and the second highest Aid flow (current US$) in 1994?
Your response must be concise. 0. What is the difference between the highest and the second highest Aid flow (current US$) in 1997?
Offer a very short reply. 8.80e+05. What is the difference between the highest and the lowest Aid flow (current US$) in 1992?
Offer a terse response. 1.15e+06. What is the difference between the highest and the lowest Aid flow (current US$) of 1994?
Offer a very short reply. 1.27e+06. What is the difference between the highest and the lowest Aid flow (current US$) in 1997?
Your answer should be compact. 2.48e+06. What is the difference between the highest and the lowest Aid flow (current US$) of 1998?
Your answer should be compact. 2.10e+06. 